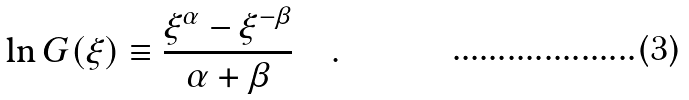<formula> <loc_0><loc_0><loc_500><loc_500>\ln G ( \xi ) \equiv \frac { \xi ^ { \alpha } - \xi ^ { - \beta } } { \alpha + \beta } \quad .</formula> 